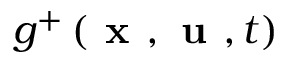Convert formula to latex. <formula><loc_0><loc_0><loc_500><loc_500>g ^ { + } \left ( x , u , t \right )</formula> 